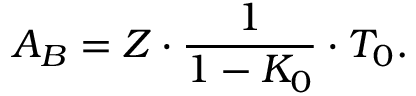Convert formula to latex. <formula><loc_0><loc_0><loc_500><loc_500>A _ { B } = Z \cdot \frac { 1 } { 1 - K _ { 0 } } \cdot T _ { 0 } .</formula> 